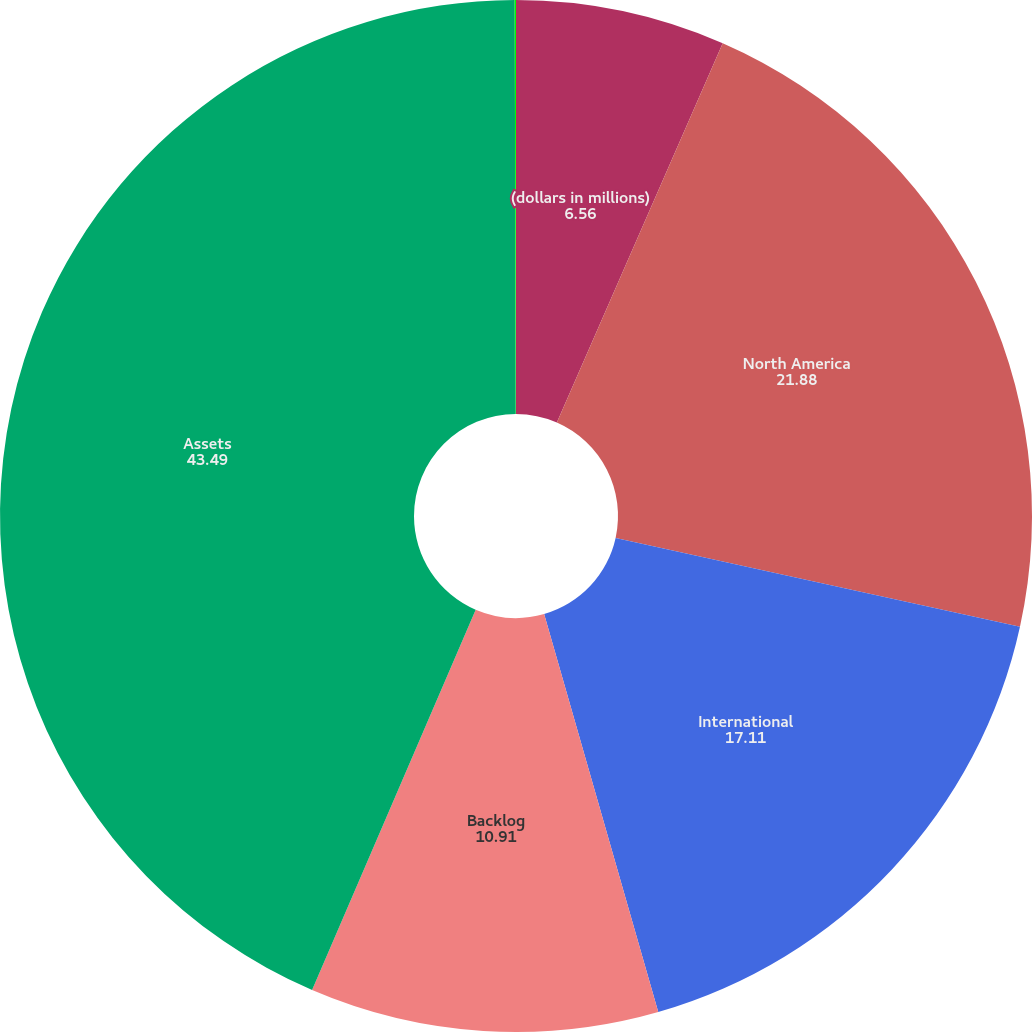Convert chart to OTSL. <chart><loc_0><loc_0><loc_500><loc_500><pie_chart><fcel>(dollars in millions)<fcel>North America<fcel>International<fcel>Backlog<fcel>Assets<fcel>Return on average assets<nl><fcel>6.56%<fcel>21.88%<fcel>17.11%<fcel>10.91%<fcel>43.49%<fcel>0.04%<nl></chart> 